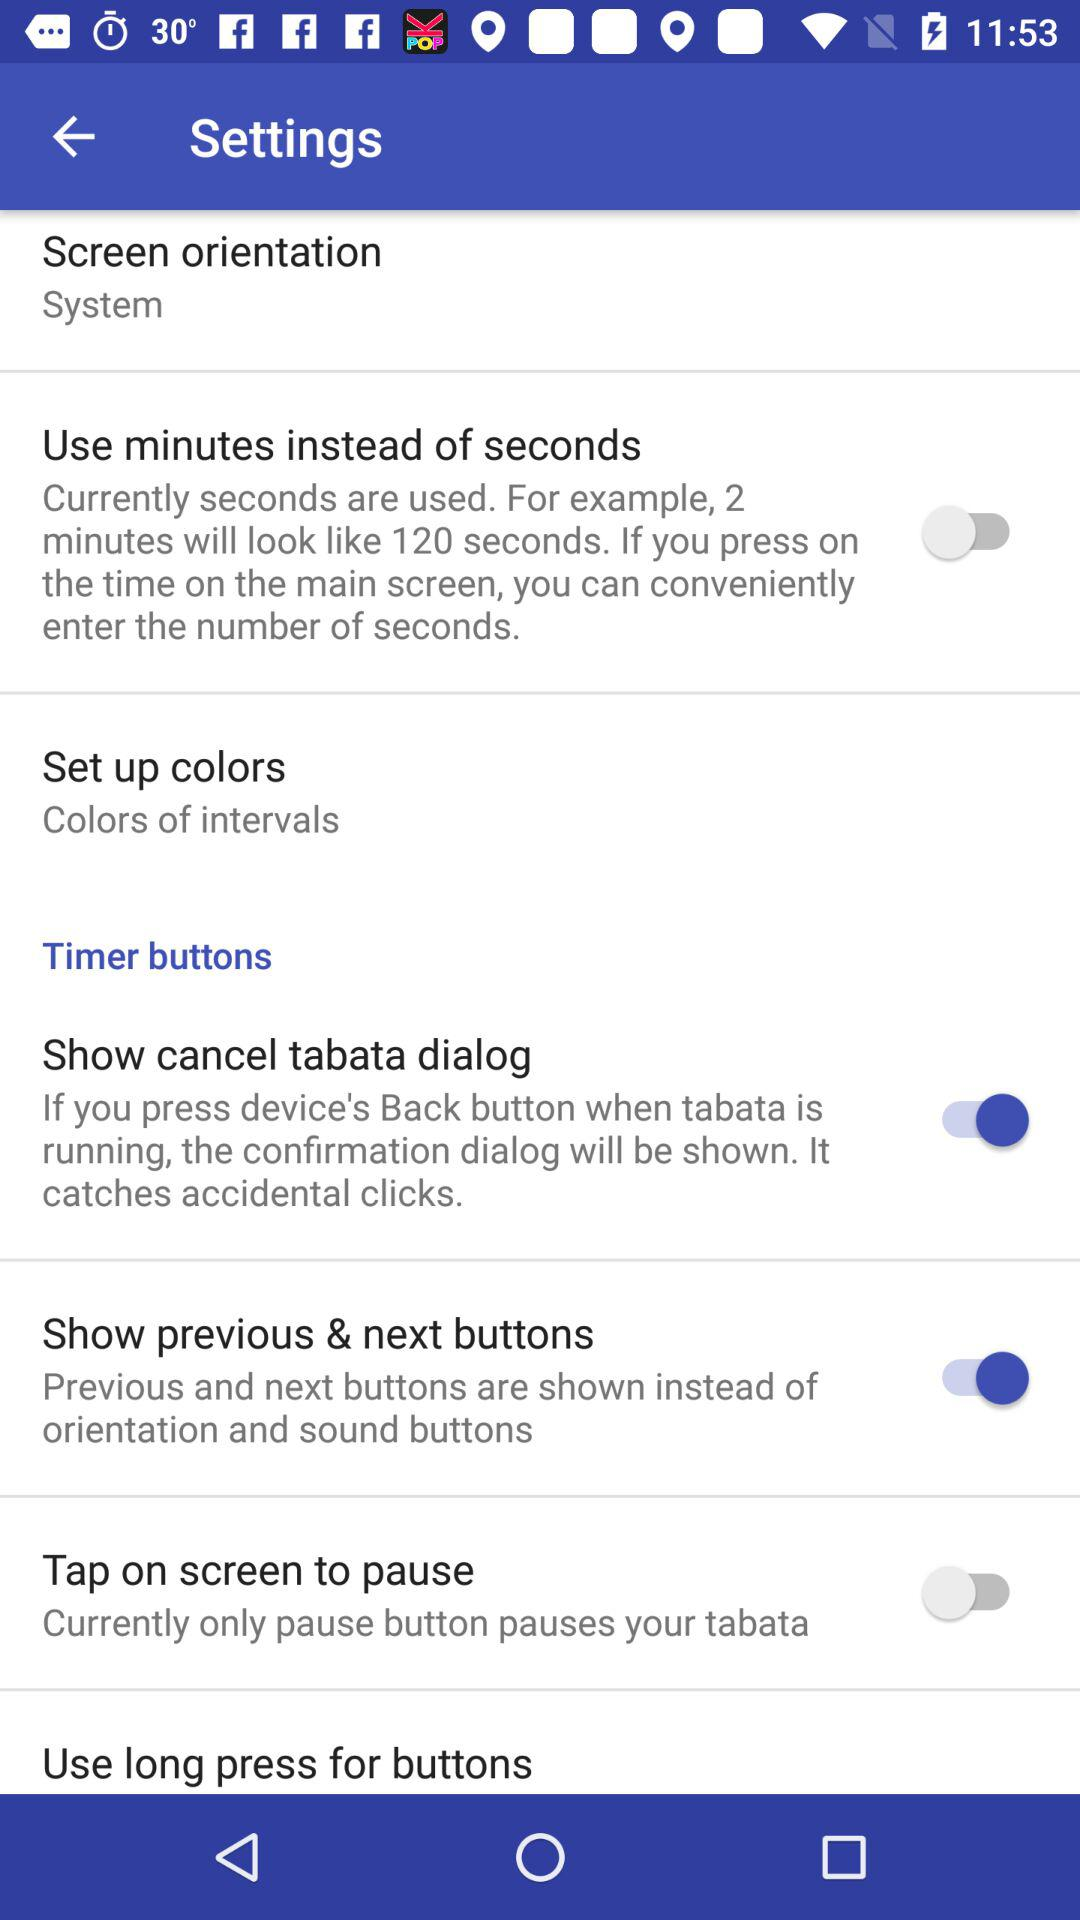What is the status of "Tap on screen to pause"? The status is "off". 